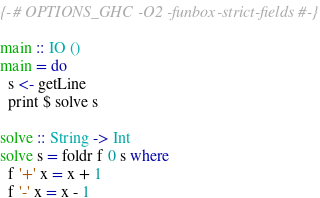Convert code to text. <code><loc_0><loc_0><loc_500><loc_500><_Haskell_>{-# OPTIONS_GHC -O2 -funbox-strict-fields #-}

main :: IO ()
main = do
  s <- getLine
  print $ solve s

solve :: String -> Int
solve s = foldr f 0 s where
  f '+' x = x + 1
  f '-' x = x - 1
</code> 